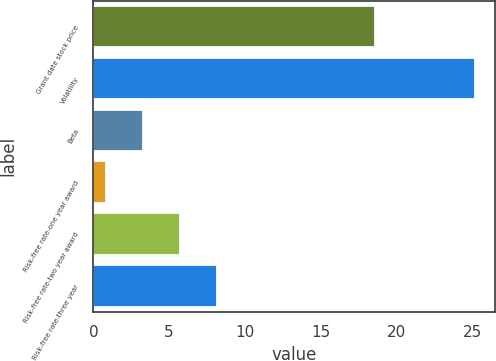Convert chart to OTSL. <chart><loc_0><loc_0><loc_500><loc_500><bar_chart><fcel>Grant date stock price<fcel>Volatility<fcel>Beta<fcel>Risk-free rate-one year award<fcel>Risk-free rate-two year award<fcel>Risk-free rate-three year<nl><fcel>18.56<fcel>25.2<fcel>3.26<fcel>0.82<fcel>5.7<fcel>8.14<nl></chart> 